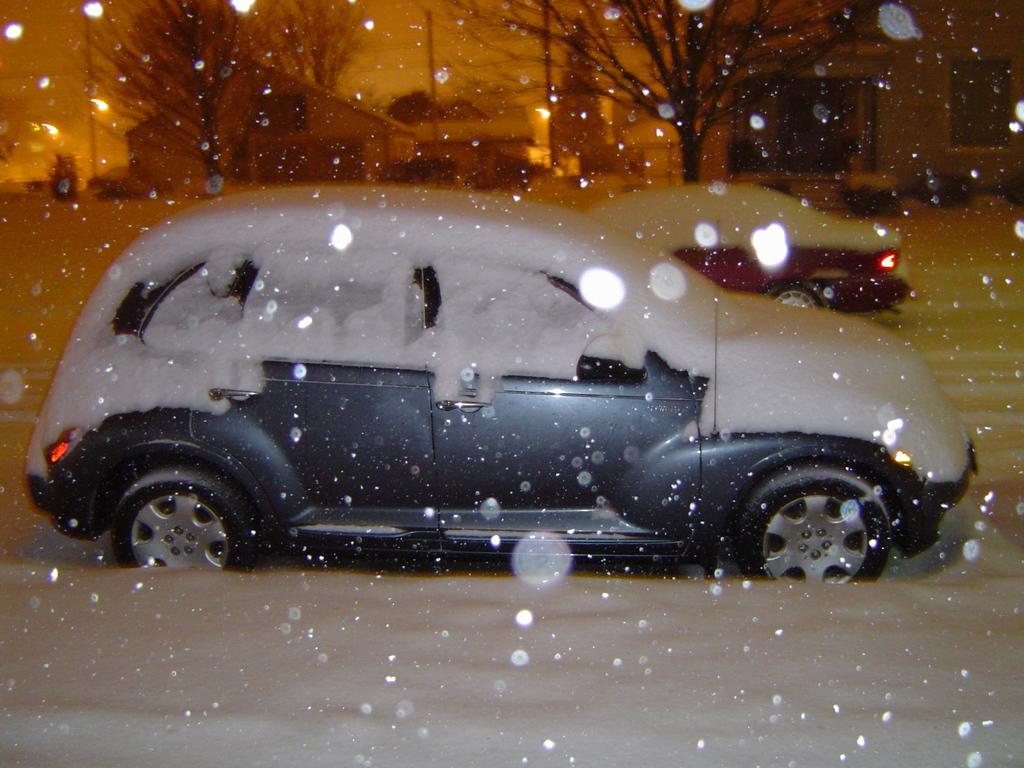What types of objects are covered with snow in the image? There are vehicles, houses, and trees in the image, and all of them are fully covered with snow. Can you describe the condition of the vehicles in the image? The vehicles in the image are fully covered with snow. What type of natural vegetation is visible in the image? There are trees in the image, and they are fully covered with snow. What type of haircut is the tree getting in the image? There is no haircut being given to the tree in the image; it is fully covered with snow. What type of pleasure can be seen being experienced by the vehicles in the image? There is no indication of pleasure being experienced by the vehicles in the image; they are simply covered with snow. 